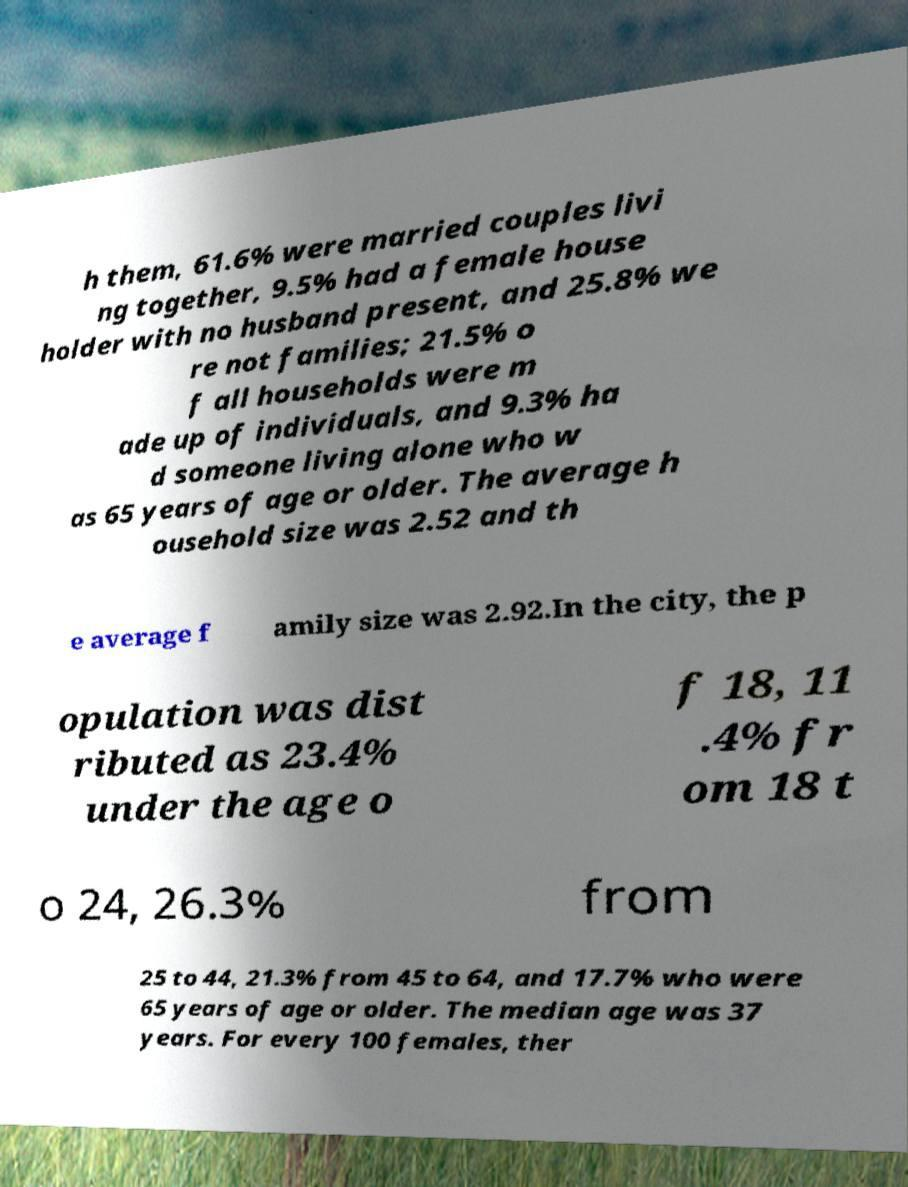Can you accurately transcribe the text from the provided image for me? h them, 61.6% were married couples livi ng together, 9.5% had a female house holder with no husband present, and 25.8% we re not families; 21.5% o f all households were m ade up of individuals, and 9.3% ha d someone living alone who w as 65 years of age or older. The average h ousehold size was 2.52 and th e average f amily size was 2.92.In the city, the p opulation was dist ributed as 23.4% under the age o f 18, 11 .4% fr om 18 t o 24, 26.3% from 25 to 44, 21.3% from 45 to 64, and 17.7% who were 65 years of age or older. The median age was 37 years. For every 100 females, ther 